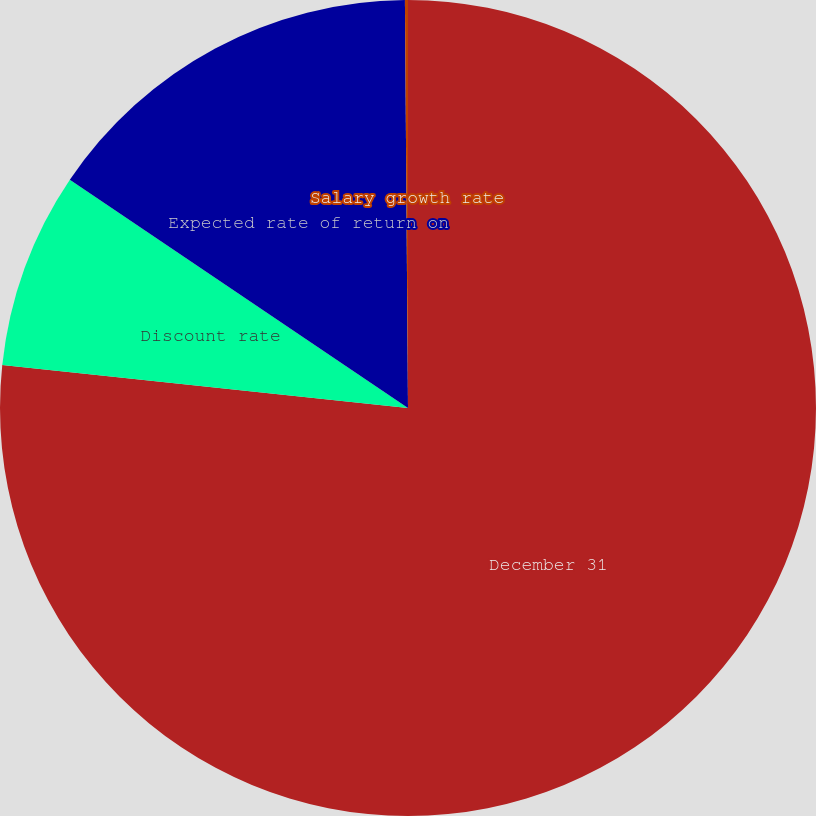<chart> <loc_0><loc_0><loc_500><loc_500><pie_chart><fcel>December 31<fcel>Discount rate<fcel>Expected rate of return on<fcel>Salary growth rate<nl><fcel>76.68%<fcel>7.77%<fcel>15.43%<fcel>0.12%<nl></chart> 